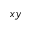Convert formula to latex. <formula><loc_0><loc_0><loc_500><loc_500>x y</formula> 